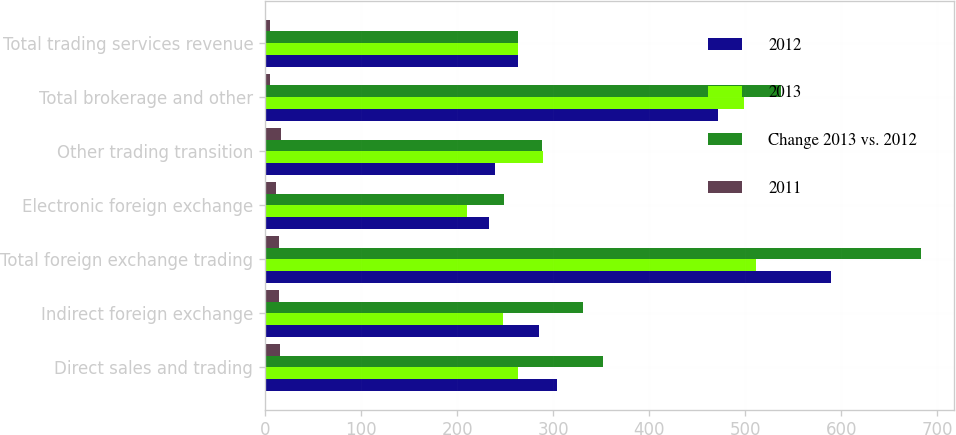Convert chart. <chart><loc_0><loc_0><loc_500><loc_500><stacked_bar_chart><ecel><fcel>Direct sales and trading<fcel>Indirect foreign exchange<fcel>Total foreign exchange trading<fcel>Electronic foreign exchange<fcel>Other trading transition<fcel>Total brokerage and other<fcel>Total trading services revenue<nl><fcel>2012<fcel>304<fcel>285<fcel>589<fcel>233<fcel>239<fcel>472<fcel>263<nl><fcel>2013<fcel>263<fcel>248<fcel>511<fcel>210<fcel>289<fcel>499<fcel>263<nl><fcel>Change 2013 vs. 2012<fcel>352<fcel>331<fcel>683<fcel>249<fcel>288<fcel>537<fcel>263<nl><fcel>2011<fcel>16<fcel>15<fcel>15<fcel>11<fcel>17<fcel>5<fcel>5<nl></chart> 